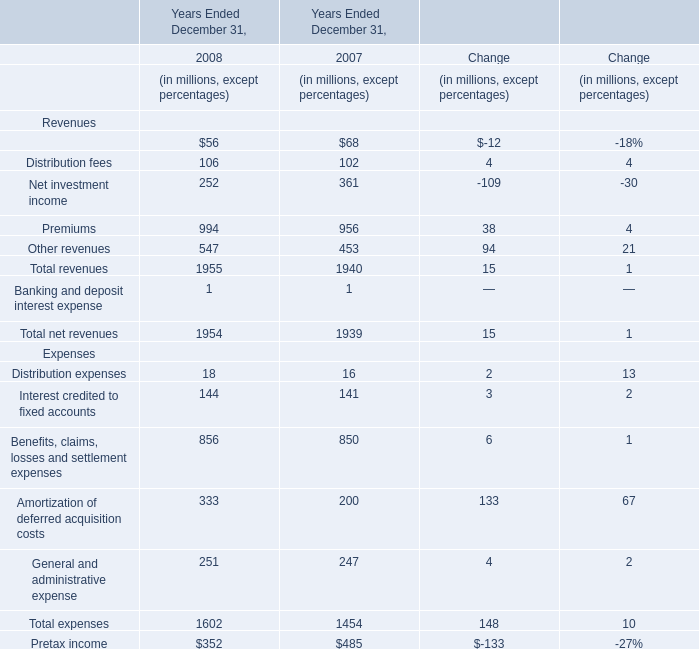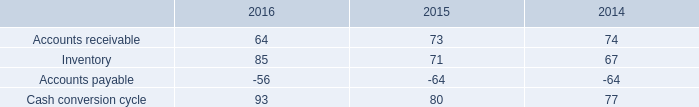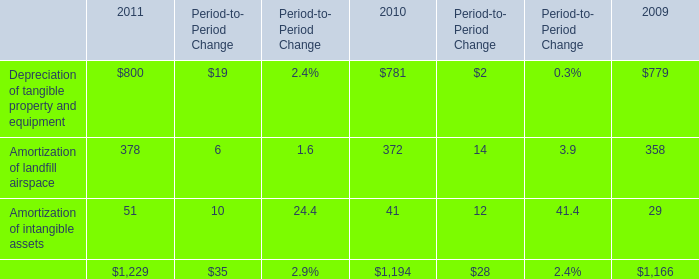What's the average of Distribution fees in 2008? (in millions) 
Answer: 106. 